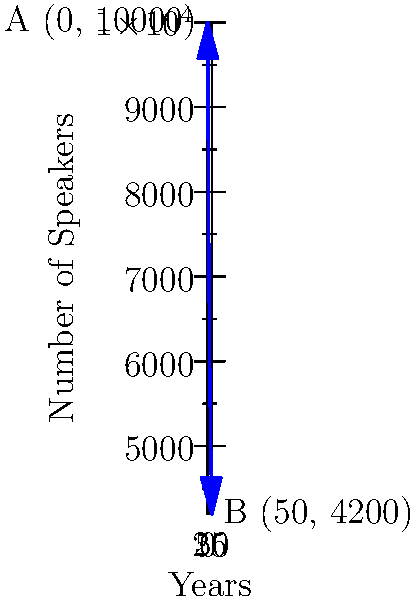The graph shows the decline of native speakers of a rare Slavic language over 50 years. If we represent the initial number of speakers as vector A(0, 10000) and the final number as vector B(50, 4200), what is the vector C that represents the total decrease in speakers over this period? Express your answer in the form C(x, y). To find the vector C that represents the total decrease in speakers, we need to subtract vector B from vector A:

1. Vector A represents the initial state: A(0, 10000)
2. Vector B represents the final state: B(50, 4200)
3. The formula for vector subtraction is: C = A - B

Let's calculate the components of C:

4. x-component: $C_x = A_x - B_x = 0 - 50 = -50$
5. y-component: $C_y = A_y - B_y = 10000 - 4200 = 5800$

Therefore, vector C can be expressed as C(-50, 5800).

The x-component (-50) represents the time span of 50 years in the negative direction (moving backwards in time).
The y-component (5800) represents the total decrease in the number of speakers over the 50-year period.
Answer: C(-50, 5800) 